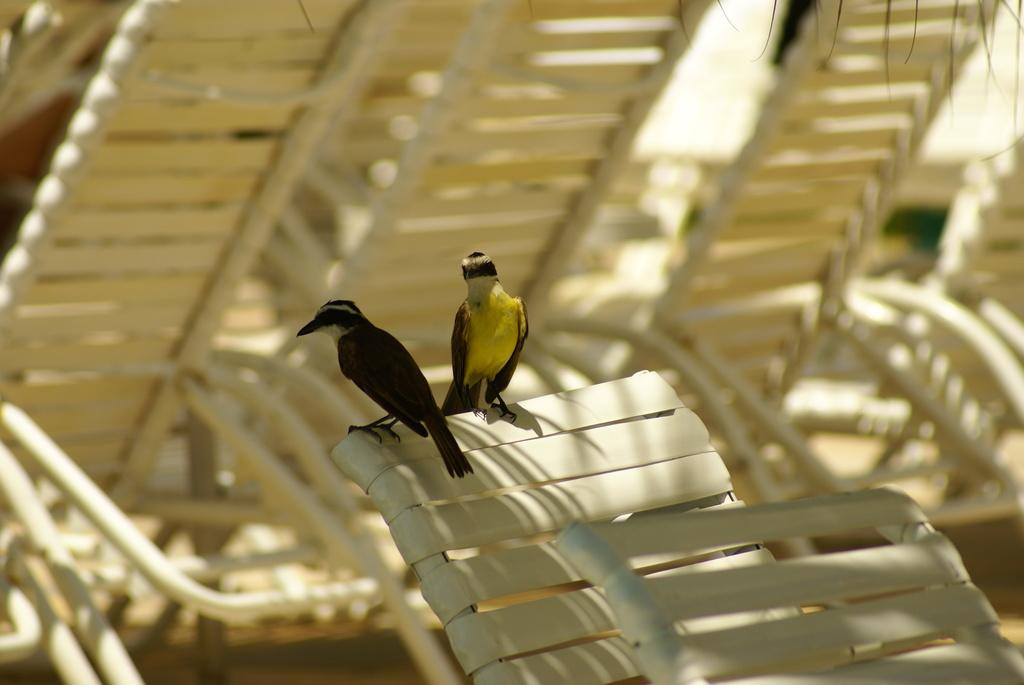What is the main subject of the image? The main subject of the image is birds. Where are the birds located in the image? The birds are on a chair in the center of the image. Are there any other chairs visible in the image? Yes, there are chairs visible in the background of the image. What invention is being demonstrated by the birds on the chair? There is no invention being demonstrated by the birds in the image; they are simply perched on a chair. What type of chalk is being used by the birds to draw on the chair? There is no chalk present in the image, and the birds are not drawing on the chair. 